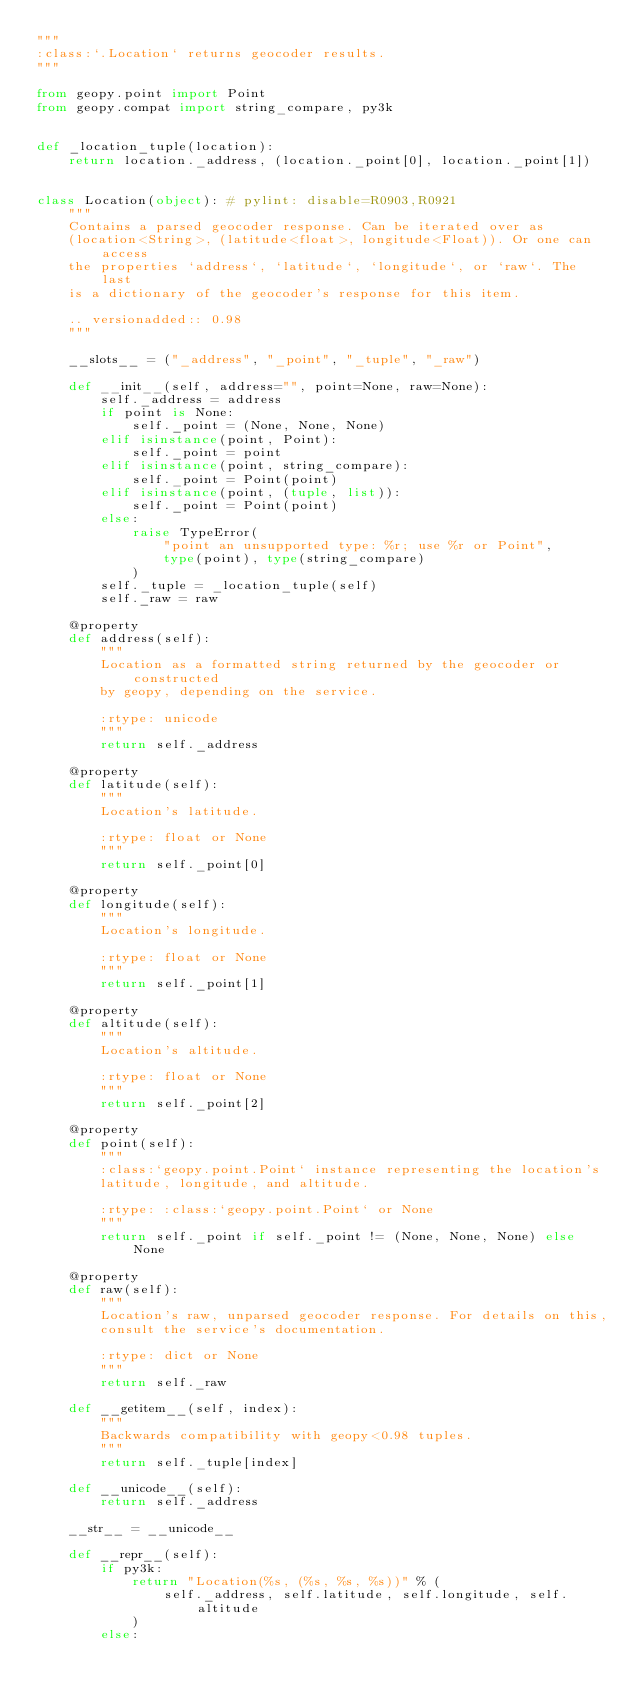<code> <loc_0><loc_0><loc_500><loc_500><_Python_>"""
:class:`.Location` returns geocoder results.
"""

from geopy.point import Point
from geopy.compat import string_compare, py3k


def _location_tuple(location):
    return location._address, (location._point[0], location._point[1])


class Location(object): # pylint: disable=R0903,R0921
    """
    Contains a parsed geocoder response. Can be iterated over as
    (location<String>, (latitude<float>, longitude<Float)). Or one can access
    the properties `address`, `latitude`, `longitude`, or `raw`. The last
    is a dictionary of the geocoder's response for this item.

    .. versionadded:: 0.98
    """

    __slots__ = ("_address", "_point", "_tuple", "_raw")

    def __init__(self, address="", point=None, raw=None):
        self._address = address
        if point is None:
            self._point = (None, None, None)
        elif isinstance(point, Point):
            self._point = point
        elif isinstance(point, string_compare):
            self._point = Point(point)
        elif isinstance(point, (tuple, list)):
            self._point = Point(point)
        else:
            raise TypeError(
                "point an unsupported type: %r; use %r or Point",
                type(point), type(string_compare)
            )
        self._tuple = _location_tuple(self)
        self._raw = raw

    @property
    def address(self):
        """
        Location as a formatted string returned by the geocoder or constructed
        by geopy, depending on the service.

        :rtype: unicode
        """
        return self._address

    @property
    def latitude(self):
        """
        Location's latitude.

        :rtype: float or None
        """
        return self._point[0]

    @property
    def longitude(self):
        """
        Location's longitude.

        :rtype: float or None
        """
        return self._point[1]

    @property
    def altitude(self):
        """
        Location's altitude.

        :rtype: float or None
        """
        return self._point[2]

    @property
    def point(self):
        """
        :class:`geopy.point.Point` instance representing the location's
        latitude, longitude, and altitude.

        :rtype: :class:`geopy.point.Point` or None
        """
        return self._point if self._point != (None, None, None) else None

    @property
    def raw(self):
        """
        Location's raw, unparsed geocoder response. For details on this,
        consult the service's documentation.

        :rtype: dict or None
        """
        return self._raw

    def __getitem__(self, index):
        """
        Backwards compatibility with geopy<0.98 tuples.
        """
        return self._tuple[index]

    def __unicode__(self):
        return self._address

    __str__ = __unicode__

    def __repr__(self):
        if py3k:
            return "Location(%s, (%s, %s, %s))" % (
                self._address, self.latitude, self.longitude, self.altitude
            )
        else:</code> 